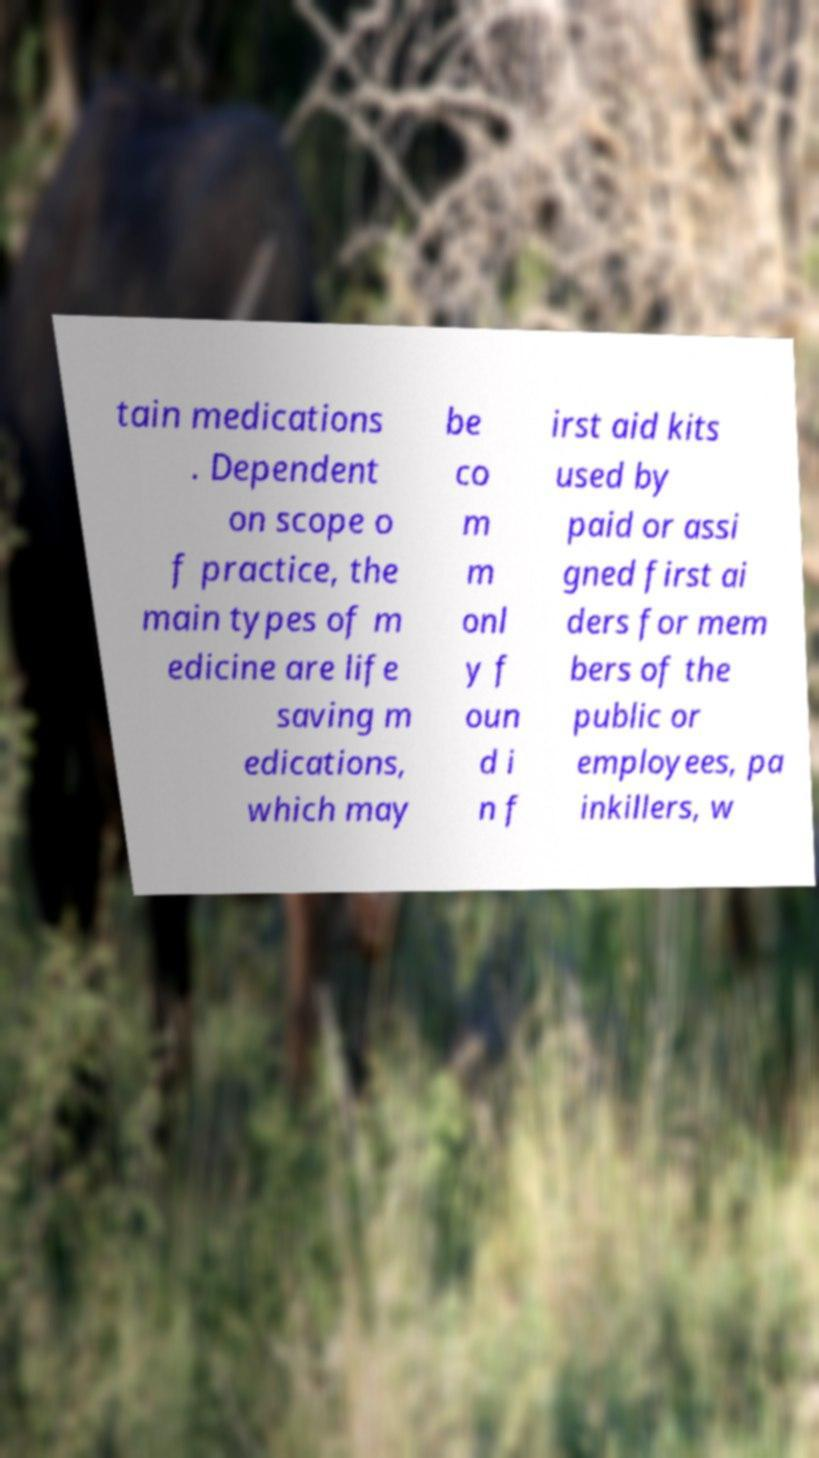What messages or text are displayed in this image? I need them in a readable, typed format. tain medications . Dependent on scope o f practice, the main types of m edicine are life saving m edications, which may be co m m onl y f oun d i n f irst aid kits used by paid or assi gned first ai ders for mem bers of the public or employees, pa inkillers, w 